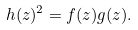Convert formula to latex. <formula><loc_0><loc_0><loc_500><loc_500>h ( z ) ^ { 2 } = f ( z ) g ( z ) .</formula> 